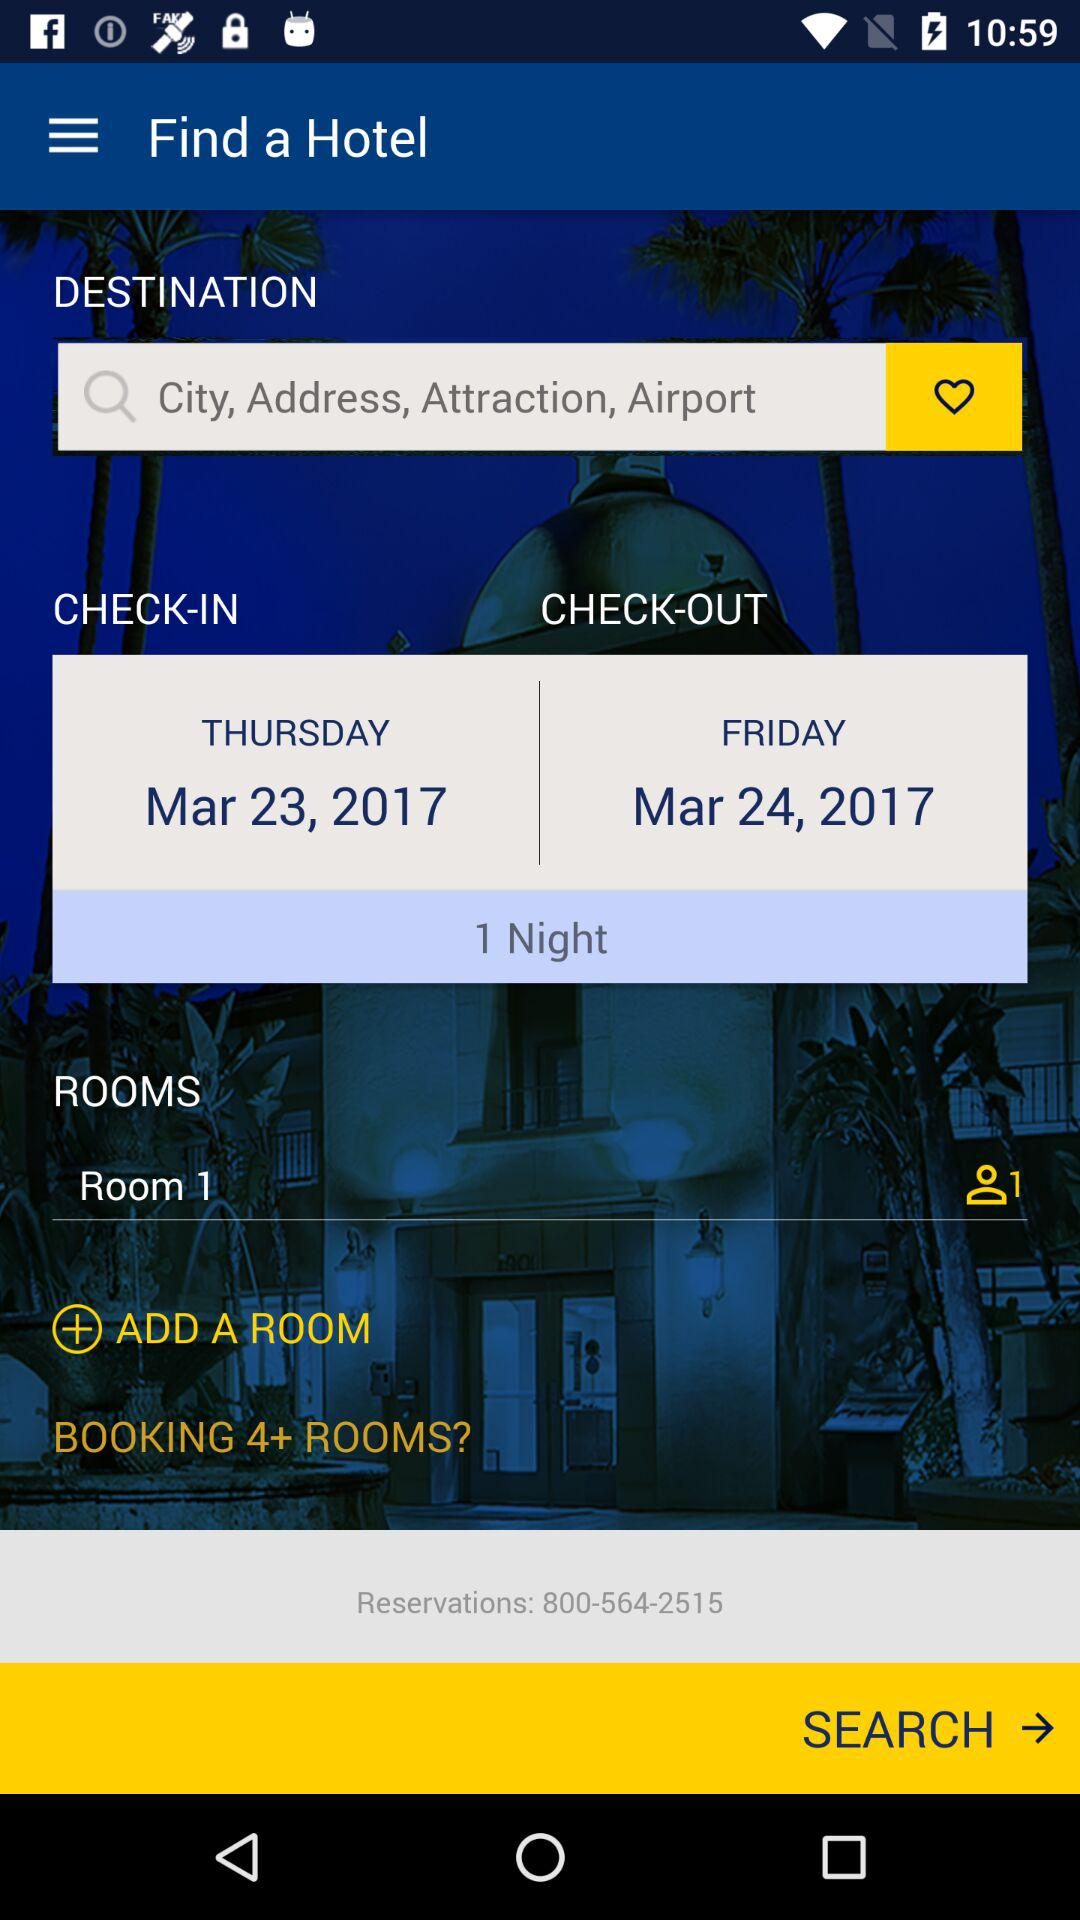For how many people is the room searched? The room is being searched for the one person. 